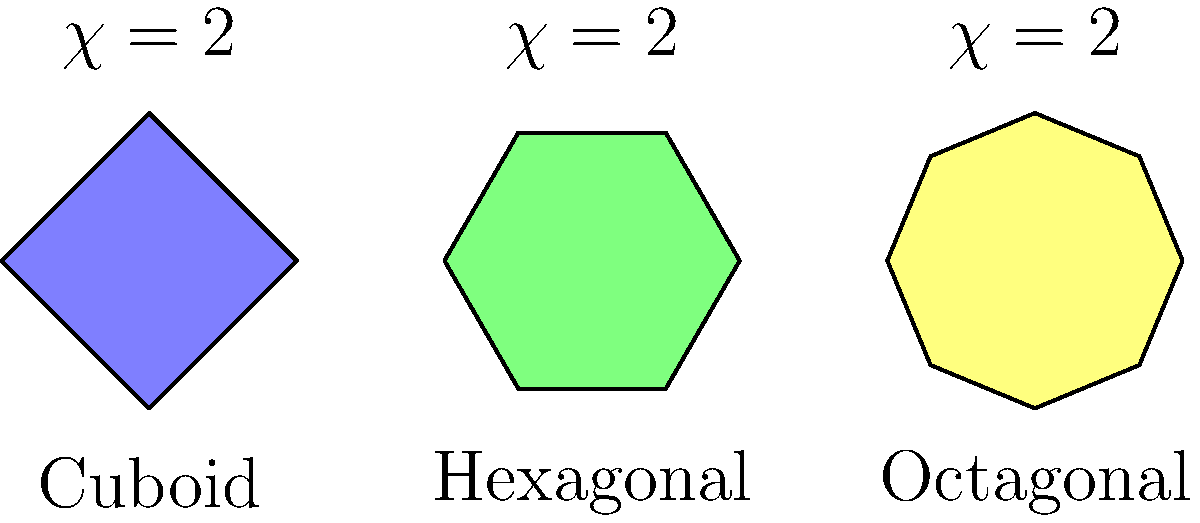Consider the simplified representations of three architectural styles commonly found in Belarusian monuments: cuboid, hexagonal, and octagonal. Each shape is topologically equivalent to a sphere. What is the sum of the Euler characteristics ($\chi$) for all three shapes combined? To solve this problem, let's follow these steps:

1. Recall the Euler characteristic formula: $\chi = V - E + F$, where V is the number of vertices, E is the number of edges, and F is the number of faces.

2. For any shape topologically equivalent to a sphere, the Euler characteristic is always 2. This is true regardless of the number of sides or faces.

3. In the diagram, we can see three shapes:
   a. Cuboid (4-sided base)
   b. Hexagonal (6-sided base)
   c. Octagonal (8-sided base)

4. Each of these shapes, when considered as a closed surface (including top and bottom), is topologically equivalent to a sphere.

5. Therefore, the Euler characteristic for each shape is 2:
   - Cuboid: $\chi = 2$
   - Hexagonal: $\chi = 2$
   - Octagonal: $\chi = 2$

6. To find the sum of the Euler characteristics, we add them together:
   $\chi_{total} = 2 + 2 + 2 = 6$

Thus, the sum of the Euler characteristics for all three shapes combined is 6.
Answer: 6 